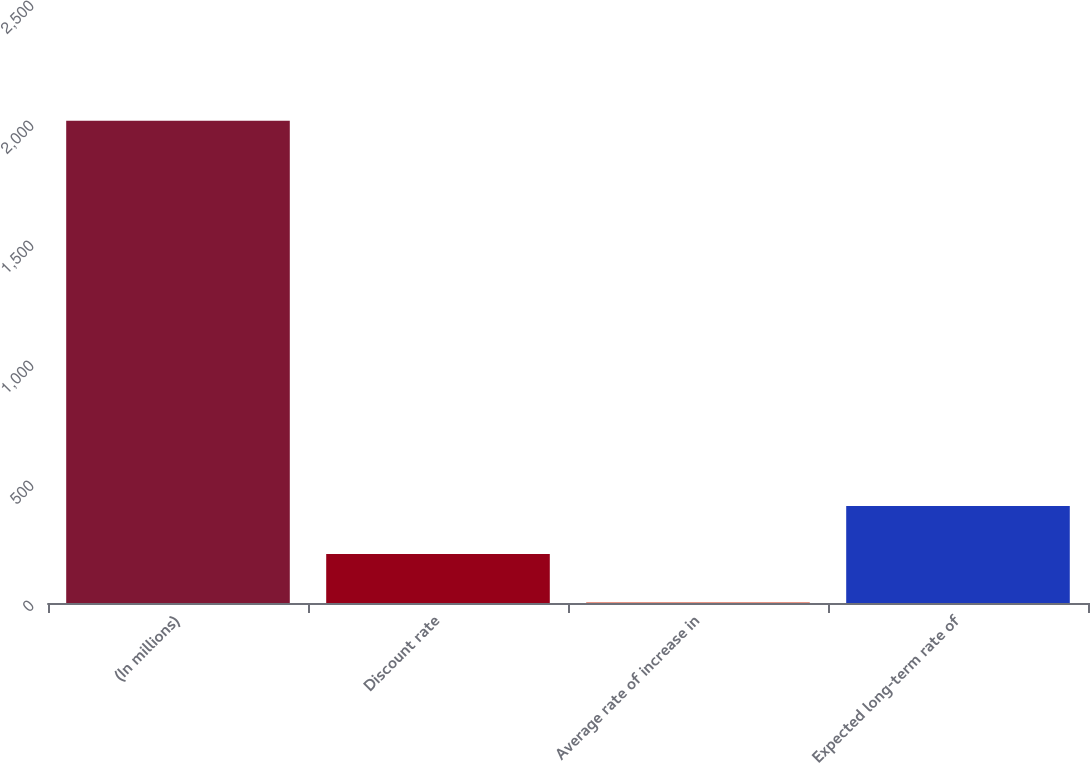Convert chart to OTSL. <chart><loc_0><loc_0><loc_500><loc_500><bar_chart><fcel>(In millions)<fcel>Discount rate<fcel>Average rate of increase in<fcel>Expected long-term rate of<nl><fcel>2009<fcel>203.86<fcel>3.29<fcel>404.43<nl></chart> 